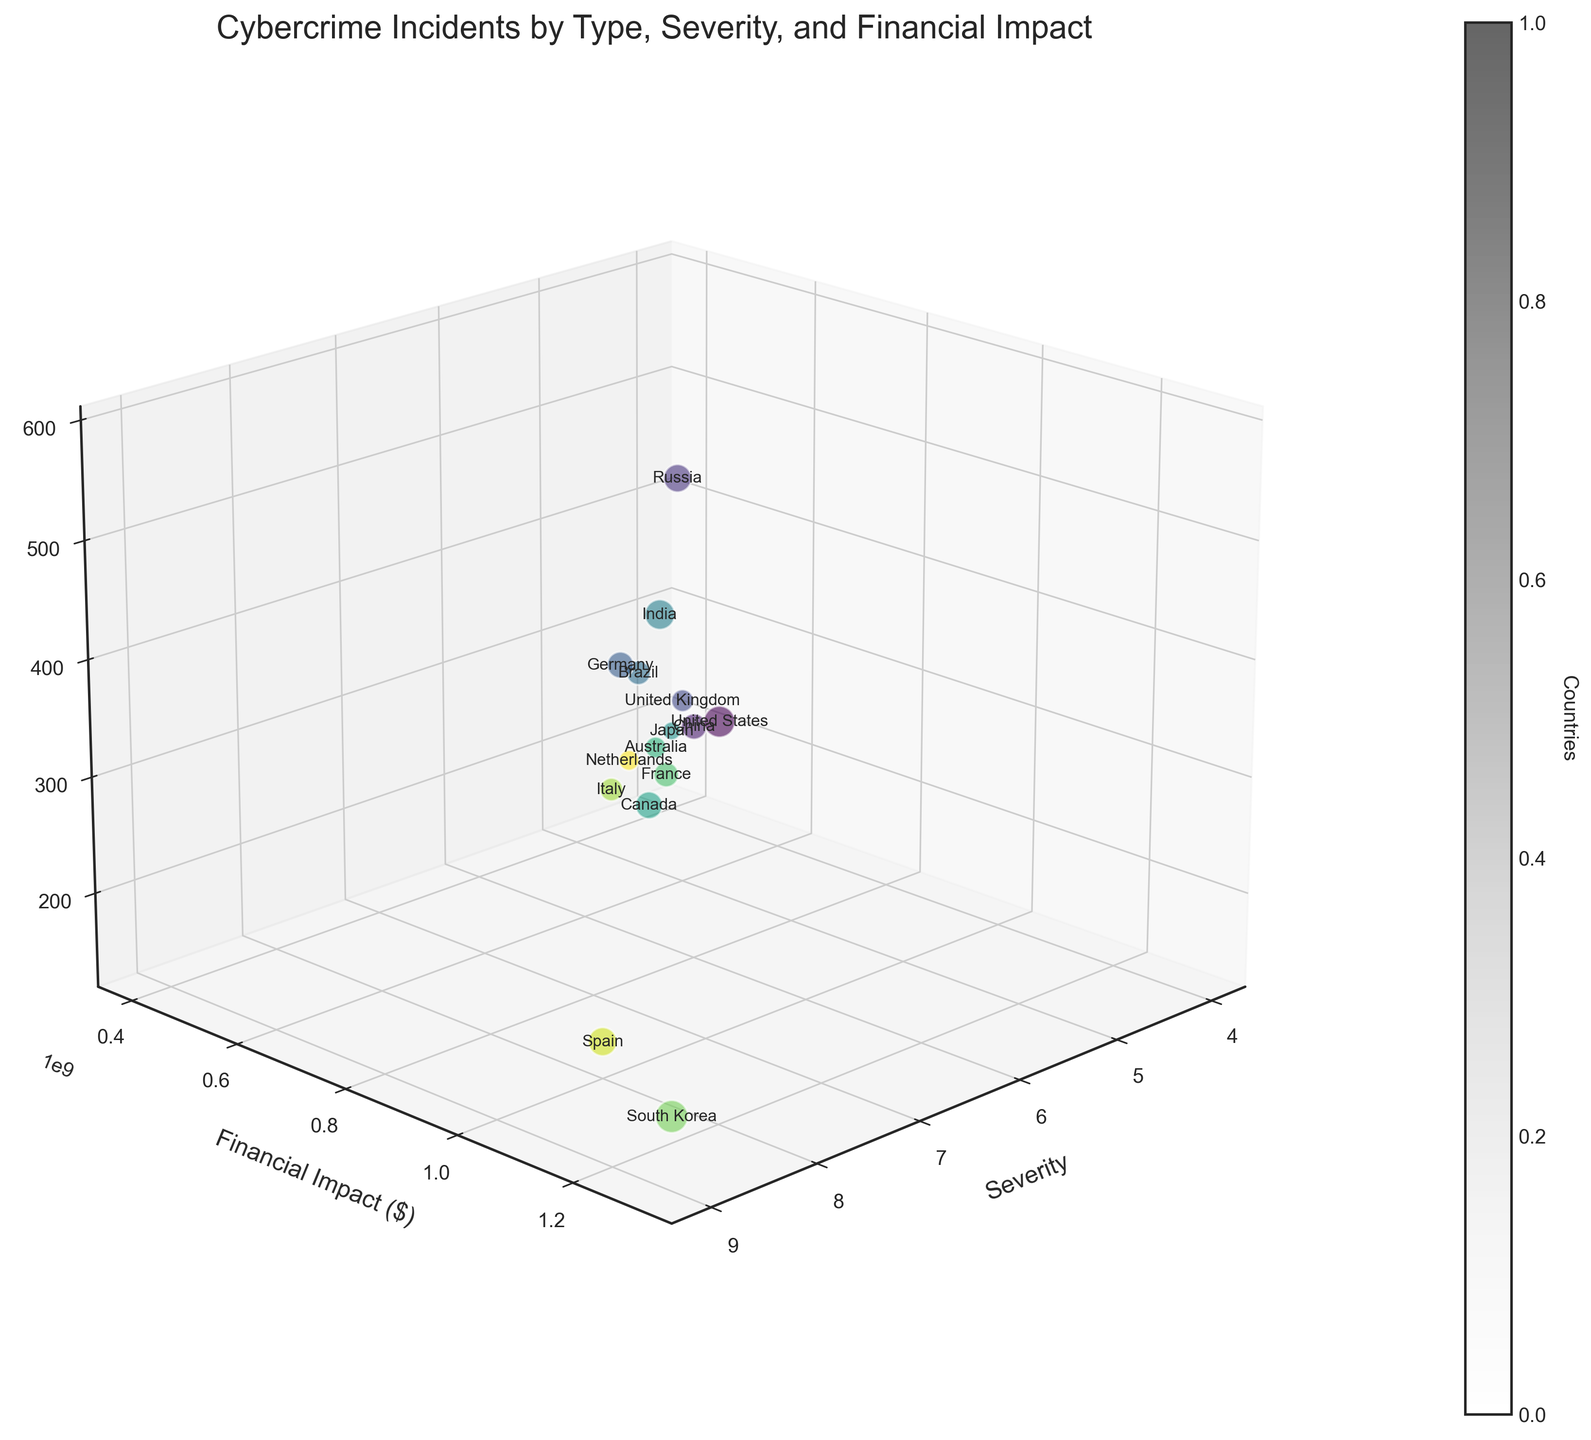what is the title of the plot? The title of the plot is written at the top of the figure and describes what the plot is about.
Answer: Cybercrime Incidents by Type, Severity, and Financial Impact How many incidents are represented by the bubble with the largest size? The size of the bubble correlates with the financial impact. The bubble with the largest size represents the country with the highest financial impact, which in this case is South Korea. The z-axis indicates the number of incidents for South Korea.
Answer: 180 Which country has the highest severity score? The x-axis shows the severity scores. By locating the point farthest along the x-axis, we can see which country it represents. South Korea has the highest severity score.
Answer: South Korea What is the financial impact for ransomware in the United States? Locate the bubble for the United States and check the y-axis value, which represents financial impact. For ransomware in the United States, the financial impact is indicated by this axis.
Answer: $1,200,000,000 Which type of cybercrime has the highest number of incidents? The z-axis indicates the number of incidents. The bubble highest on the z-axis represents the type of cybercrime with the most incidents. Russia, dealing with phishing, has the highest number of incidents.
Answer: Phishing How does the severity of a data breach in India compare to identity theft in the United Kingdom? Locate the bubbles for India (Data Breach) and the United Kingdom (Identity Theft) and compare their x-axis positions, which represents severity. India's data breach has a severity of 8, and the United Kingdom's identity theft has a severity of 5.
Answer: Data Breach is higher What is the average financial impact of the incidents in the United States and India? Locate the bubbles for the United States and India. Note their financial impacts on the y-axis ($1,200,000,000 and $1,100,000,000). Sum these values and divide by 2 to get the average. ($1,200,000,000 + $1,100,000,000) / 2 = $1,150,000,000
Answer: $1,150,000,000 Which country has the highest financial impact per incident? To determine the highest financial impact per incident, we need to divide the financial impact by the number of incidents for each country, and then compare. For South Korea: $1,300,000,000 / 180 = $7,222,222. Check other countries to find the highest value. South Korea's value is the highest.
Answer: South Korea What is the average severity of the cybercrimes depicted in the plot? Summing the severity scores of each country (8 + 6 + 7 + 5 + 7 + 6 + 8 + 4 + 7 + 5 + 6 + 9 + 6 + 8 + 5) and dividing by the total number of countries (15) gives us the average. (8 + 6 + 7 + 5 + 7 + 6 + 8 + 4 + 7 + 5 + 6 + 9 + 6 + 8 + 5)/ 15 = 6.33
Answer: 6.33 Which cybercrime type has the lowest severity? Locate the bubble closest to the origin along the x-axis, which represents the severity. Japan's Cryptojacking with severity 4 is the lowest among all types.
Answer: Cryptojacking 